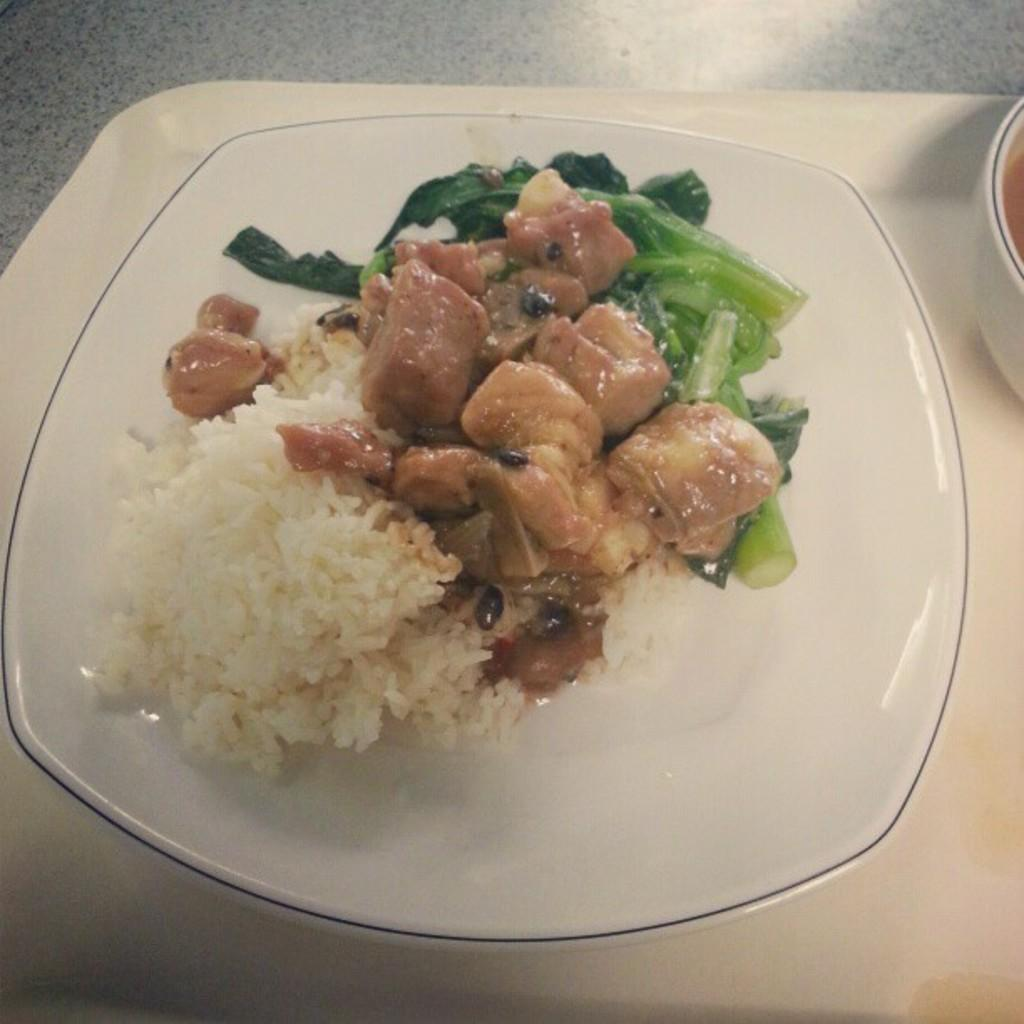What is on the plate that is visible in the image? The plate contains rice and other food items. What else can be seen on the right side of the image? There is a bowl on the right side of the image. How are the plate and bowl arranged in the image? The plate and bowl are placed on a tray. Where is the tray located in the image? The tray is on a table. What type of bird is sitting on the fork in the image? There is no bird or fork present in the image. 